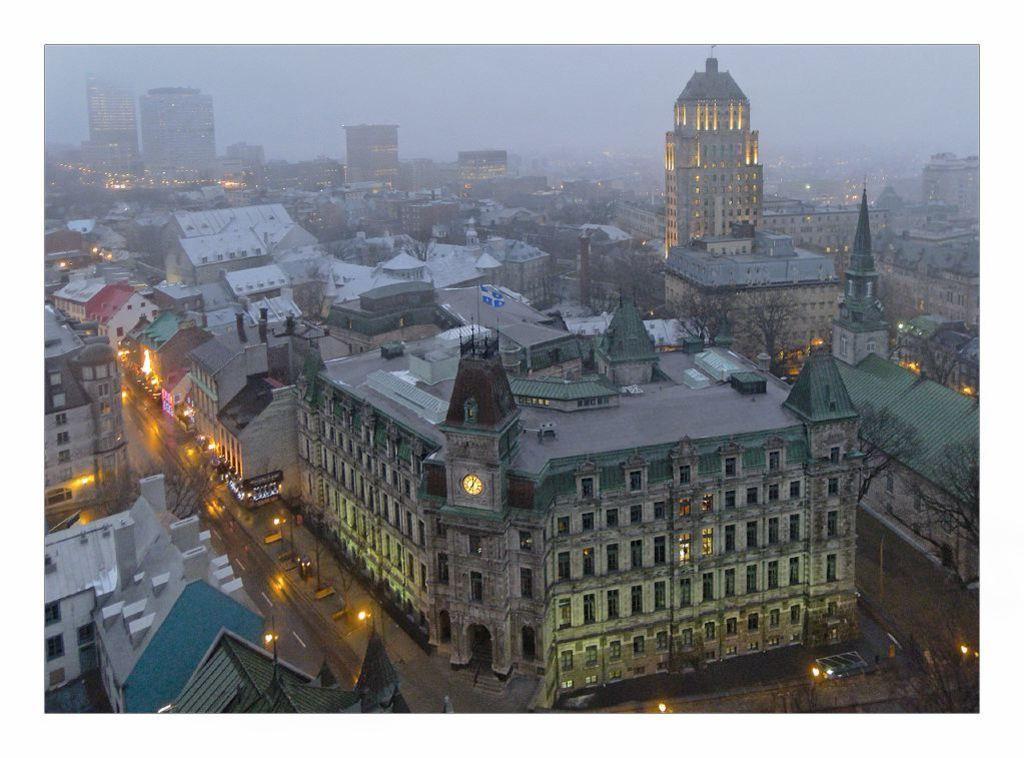Can you describe this image briefly? In this image I can see few buildings, windows, poles, trees, lights, sky and the clock is attached to the wall. 